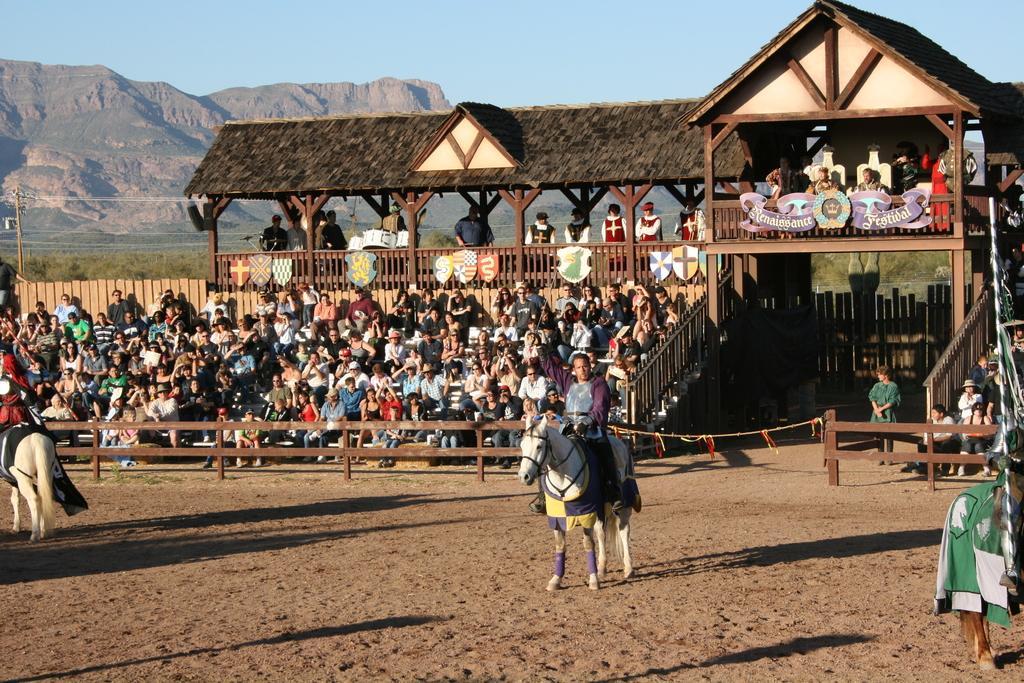How would you summarize this image in a sentence or two? In this image we can see people sitting on horses. In the background of the image there are people sitting in stands. At the bottom of the image there is sand. In the background of the image there are mountains, sky, trees. 